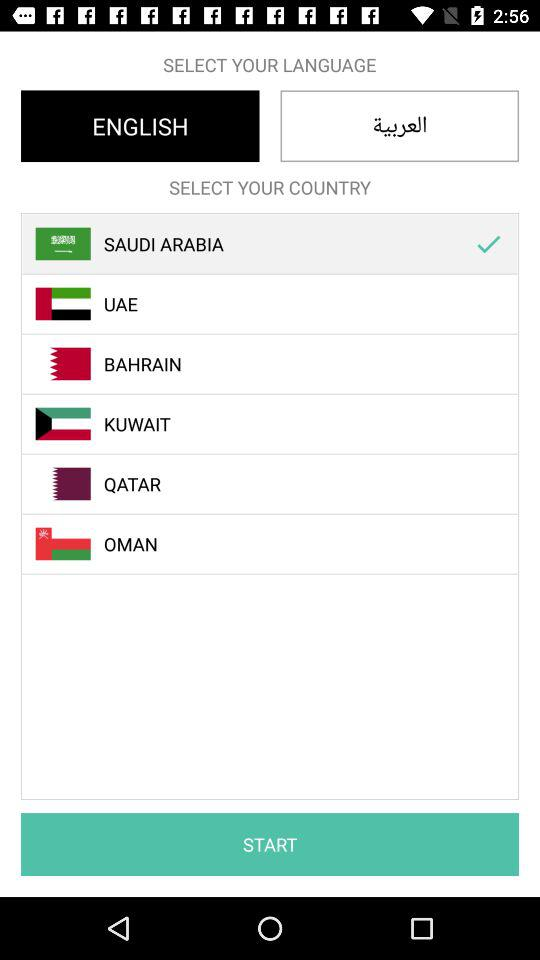Which country is selected? The selected country is Saudi Arabia. 